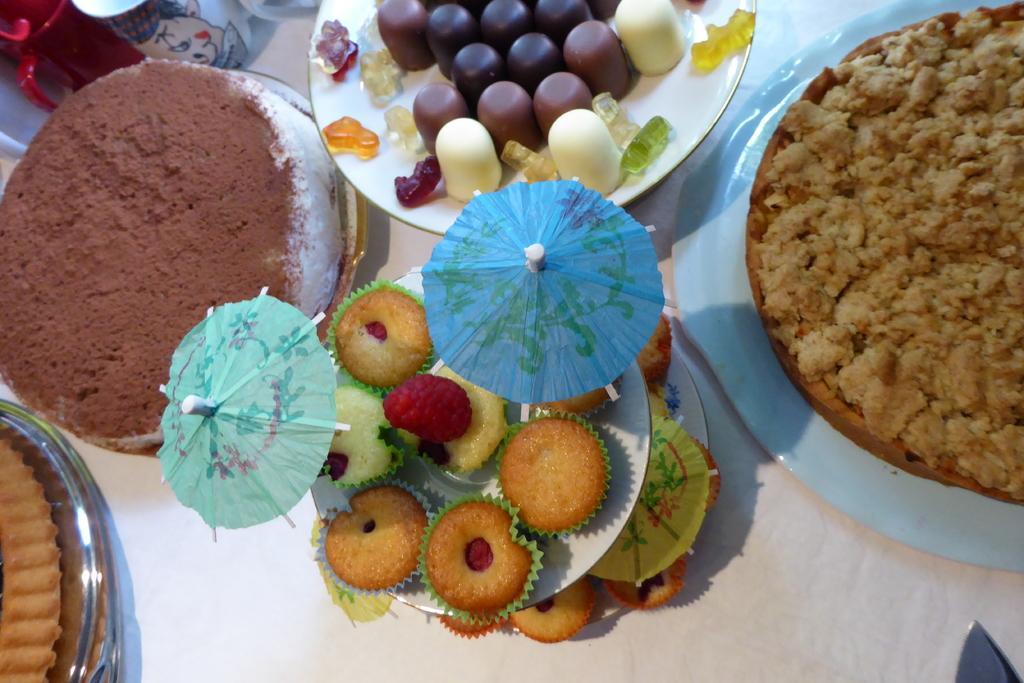Describe this image in one or two sentences. In this picture we can see there are plates, paper umbrellas and on the plates there are some food items. At the top left corner of the image, there are cups. At the bottom right corner of the image, there is an object. 